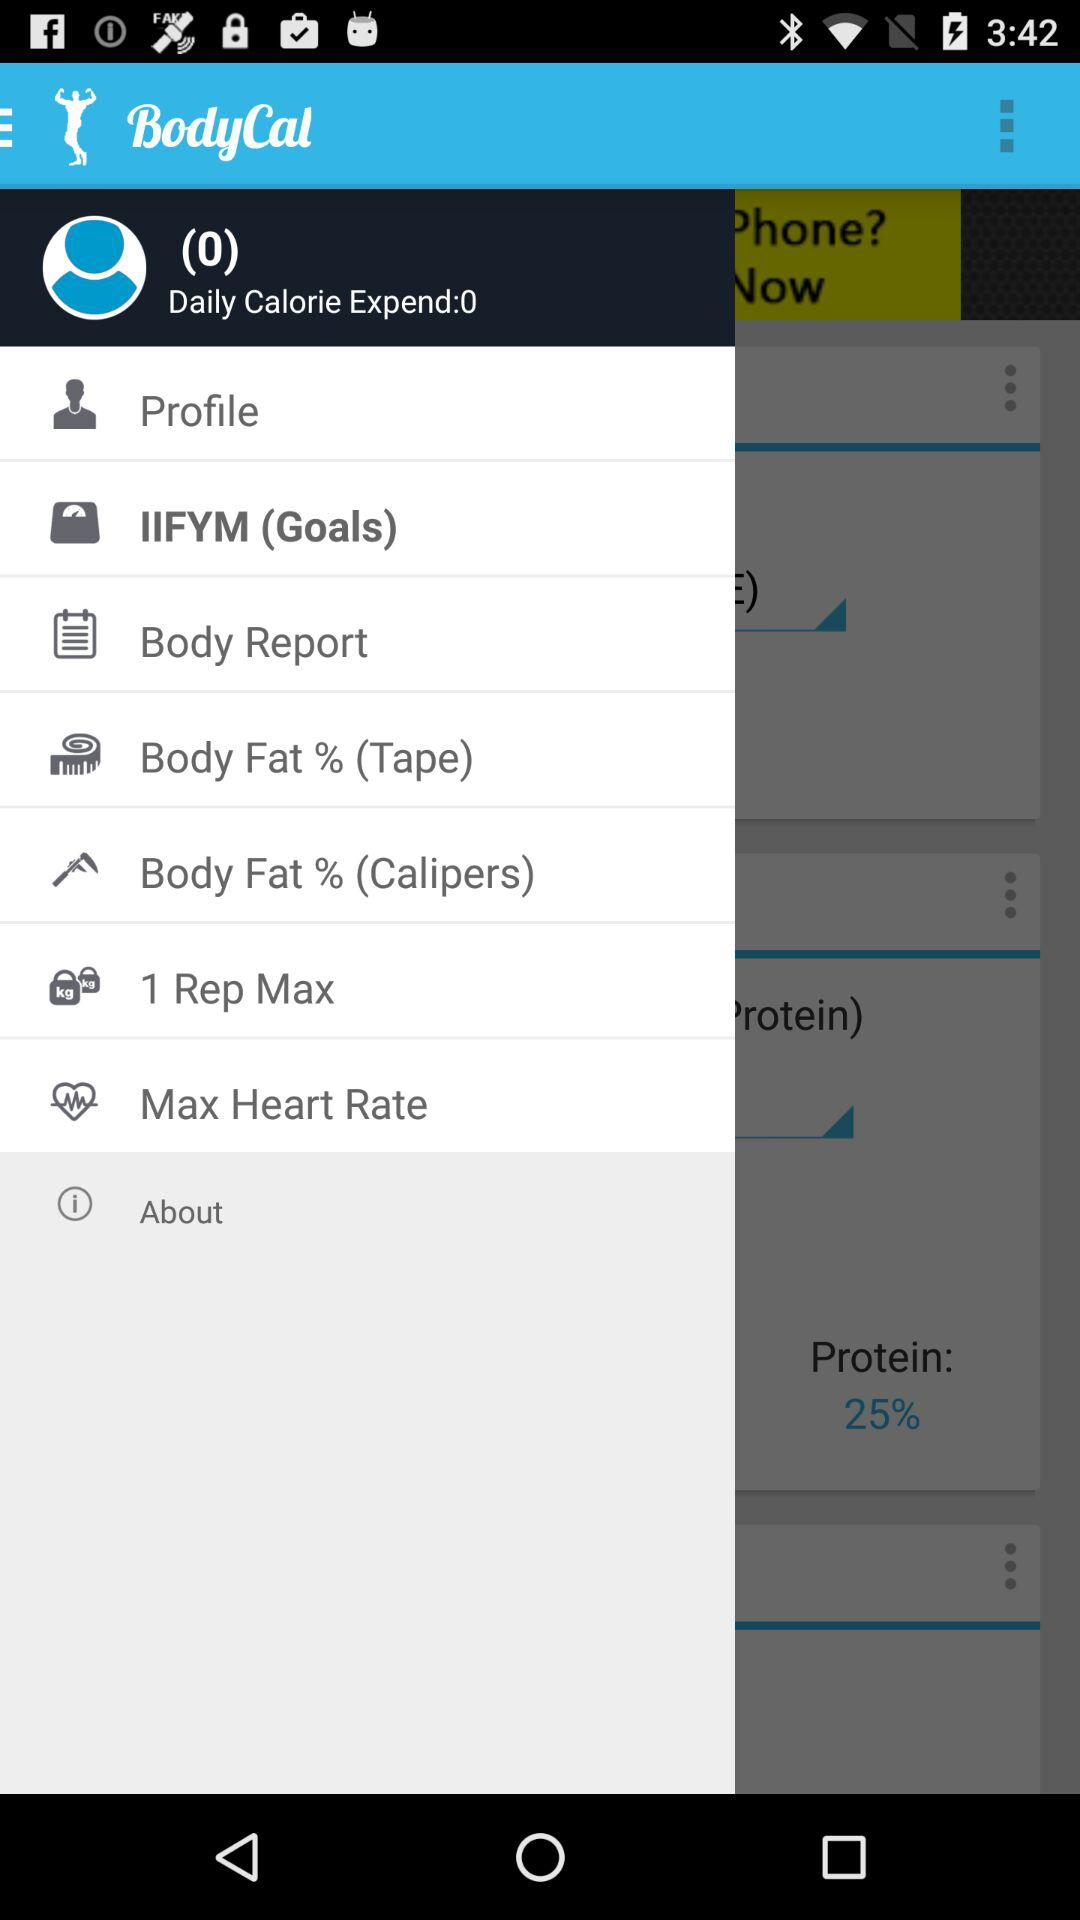What is the percentage of protein in my diet?
Answer the question using a single word or phrase. 25% 